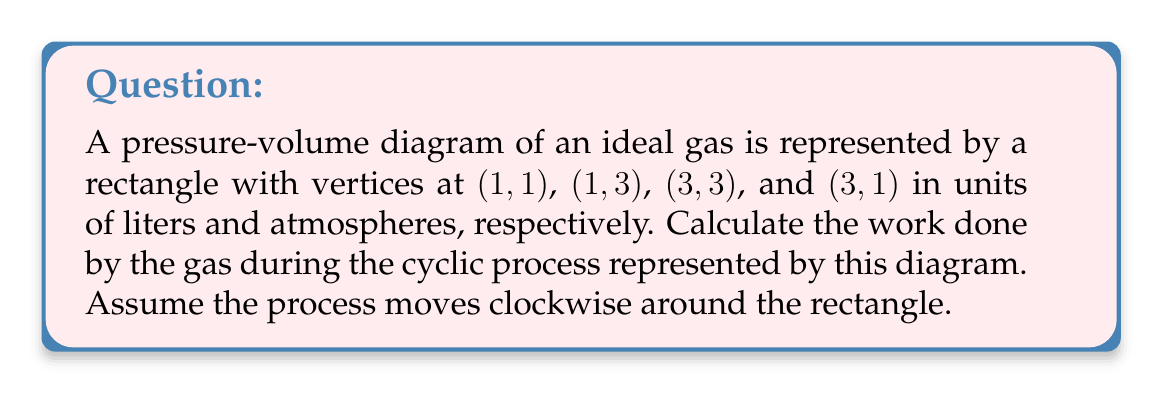Teach me how to tackle this problem. To solve this problem without relying on color distinctions, we'll follow these steps:

1) The work done by a gas in a cyclic process is equal to the area enclosed by the curve in the P-V diagram. In this case, it's the area of the rectangle.

2) The area of a rectangle is given by:
   $$ A = l \times w $$
   where $A$ is the area, $l$ is the length, and $w$ is the width.

3) From the given coordinates:
   - The width (change in volume) is: $3 - 1 = 2$ liters
   - The height (change in pressure) is: $3 - 1 = 2$ atmospheres

4) Calculate the area:
   $$ A = 2 \text{ L} \times 2 \text{ atm} = 4 \text{ L} \cdot \text{atm} $$

5) The work done by the gas is equal to this area. However, we need to convert L·atm to joules:
   $$ 1 \text{ L} \cdot \text{atm} = 101.325 \text{ J} $$

6) Therefore, the work done is:
   $$ W = 4 \text{ L} \cdot \text{atm} \times 101.325 \text{ J}/(\text{L} \cdot \text{atm}) = 405.3 \text{ J} $$
Answer: 405.3 J 